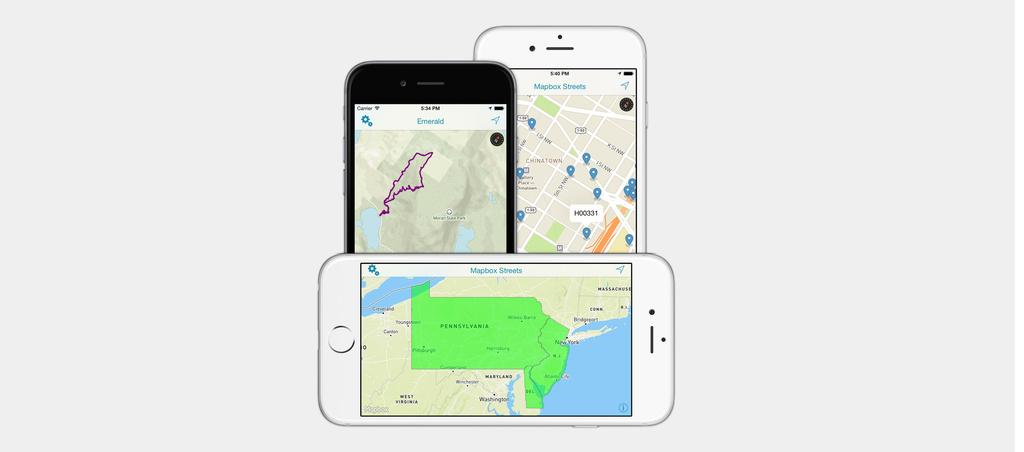Provide a one-sentence caption for the provided image. Two white cell phones showing the Mapbox Streets app and and one black cell phone showing an Emerald map app. 